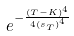<formula> <loc_0><loc_0><loc_500><loc_500>e ^ { - \frac { ( T - K ) ^ { 4 } } { 4 { ( s _ { T } ) } ^ { 4 } } }</formula> 